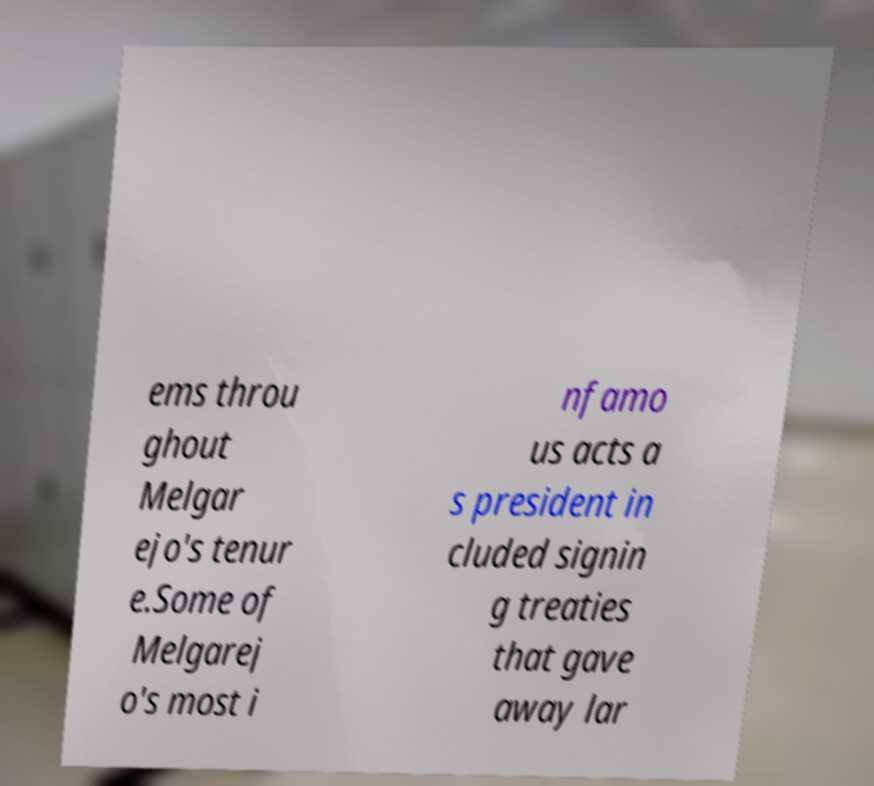Can you accurately transcribe the text from the provided image for me? ems throu ghout Melgar ejo's tenur e.Some of Melgarej o's most i nfamo us acts a s president in cluded signin g treaties that gave away lar 